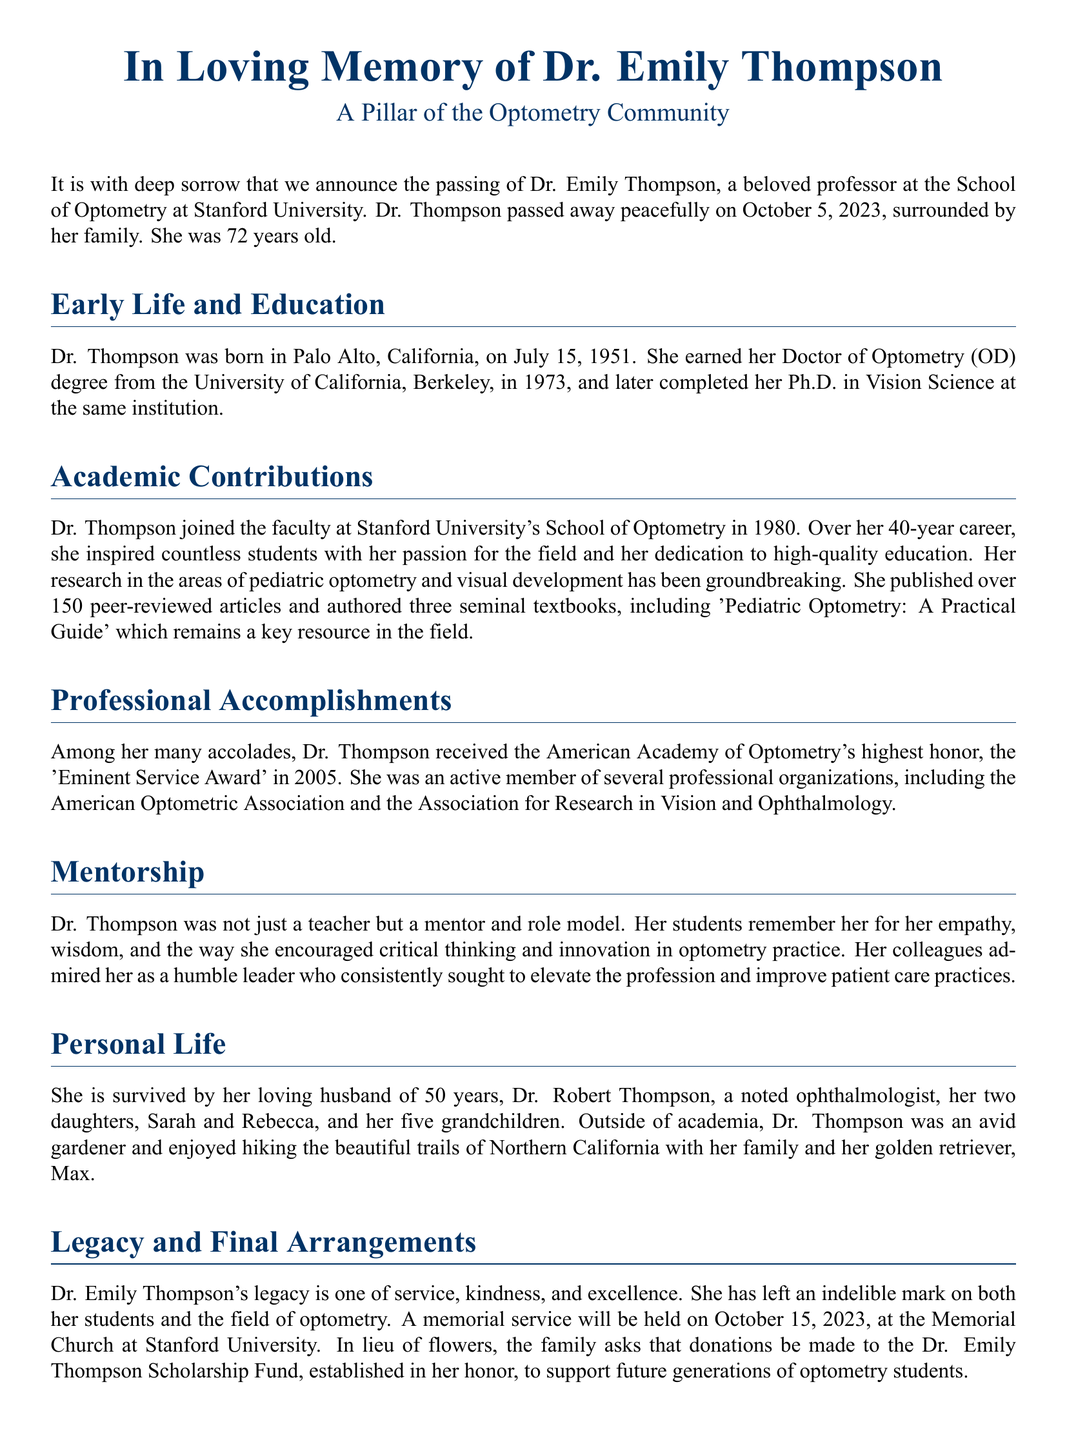What is the full name of the professor? The document provides the full name of the professor as Dr. Emily Thompson.
Answer: Dr. Emily Thompson When did Dr. Thompson earn her OD degree? The document states that Dr. Thompson earned her Doctor of Optometry (OD) degree in 1973.
Answer: 1973 What organization awarded Dr. Thompson the Eminent Service Award? The document mentions the American Academy of Optometry as the organization that awarded Dr. Thompson the Eminent Service Award.
Answer: American Academy of Optometry How many grandchildren did Dr. Thompson have? The document indicates that Dr. Thompson had five grandchildren.
Answer: five What year did Dr. Thompson pass away? The document notes that Dr. Thompson passed away on October 5, 2023.
Answer: 2023 Which book authored by Dr. Thompson is a key resource in optometry? The document specifies 'Pediatric Optometry: A Practical Guide' as a key resource authored by Dr. Thompson.
Answer: Pediatric Optometry: A Practical Guide What is Dr. Thompson's legacy described as? The document describes Dr. Thompson's legacy as one of service, kindness, and excellence.
Answer: service, kindness, and excellence What activity did Dr. Thompson enjoy outside of academia? The document mentions that Dr. Thompson was an avid gardener.
Answer: gardening When is the memorial service for Dr. Thompson scheduled? The document states that the memorial service will be held on October 15, 2023.
Answer: October 15, 2023 